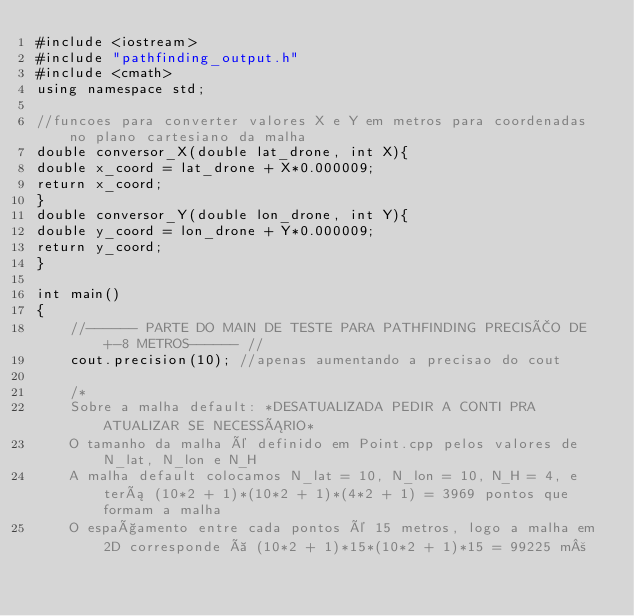Convert code to text. <code><loc_0><loc_0><loc_500><loc_500><_C++_>#include <iostream>
#include "pathfinding_output.h"
#include <cmath>
using namespace std;

//funcoes para converter valores X e Y em metros para coordenadas no plano cartesiano da malha
double conversor_X(double lat_drone, int X){
double x_coord = lat_drone + X*0.000009;
return x_coord;
}
double conversor_Y(double lon_drone, int Y){
double y_coord = lon_drone + Y*0.000009;
return y_coord;
}

int main()
{
    //------ PARTE DO MAIN DE TESTE PARA PATHFINDING PRECISÃO DE +-8 METROS------ //
    cout.precision(10); //apenas aumentando a precisao do cout

    /*
    Sobre a malha default: *DESATUALIZADA PEDIR A CONTI PRA ATUALIZAR SE NECESSÁRIO*
    O tamanho da malha é definido em Point.cpp pelos valores de N_lat, N_lon e N_H
    A malha default colocamos N_lat = 10, N_lon = 10, N_H = 4, e terá (10*2 + 1)*(10*2 + 1)*(4*2 + 1) = 3969 pontos que formam a malha
    O espaçamento entre cada pontos é 15 metros, logo a malha em 2D corresponde à (10*2 + 1)*15*(10*2 + 1)*15 = 99225 m²</code> 